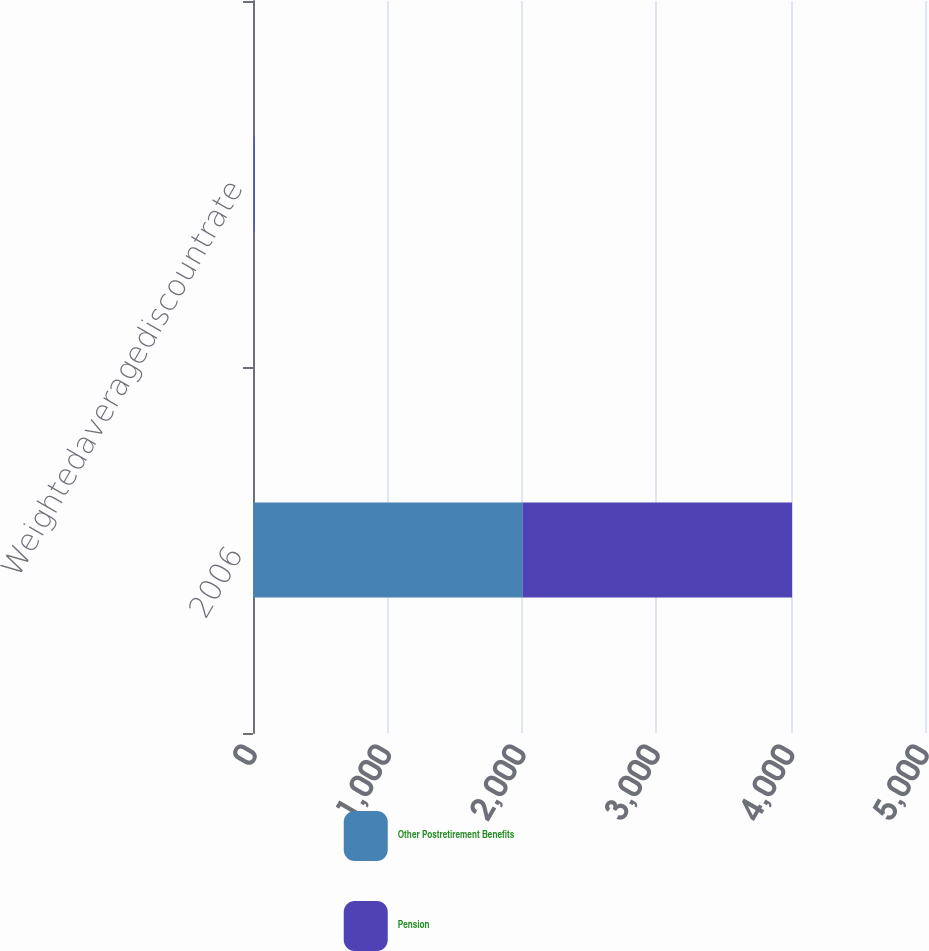<chart> <loc_0><loc_0><loc_500><loc_500><stacked_bar_chart><ecel><fcel>2006<fcel>Weightedaveragediscountrate<nl><fcel>Other Postretirement Benefits<fcel>2005<fcel>5.82<nl><fcel>Pension<fcel>2006<fcel>6<nl></chart> 